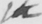What text is written in this handwritten line? the 